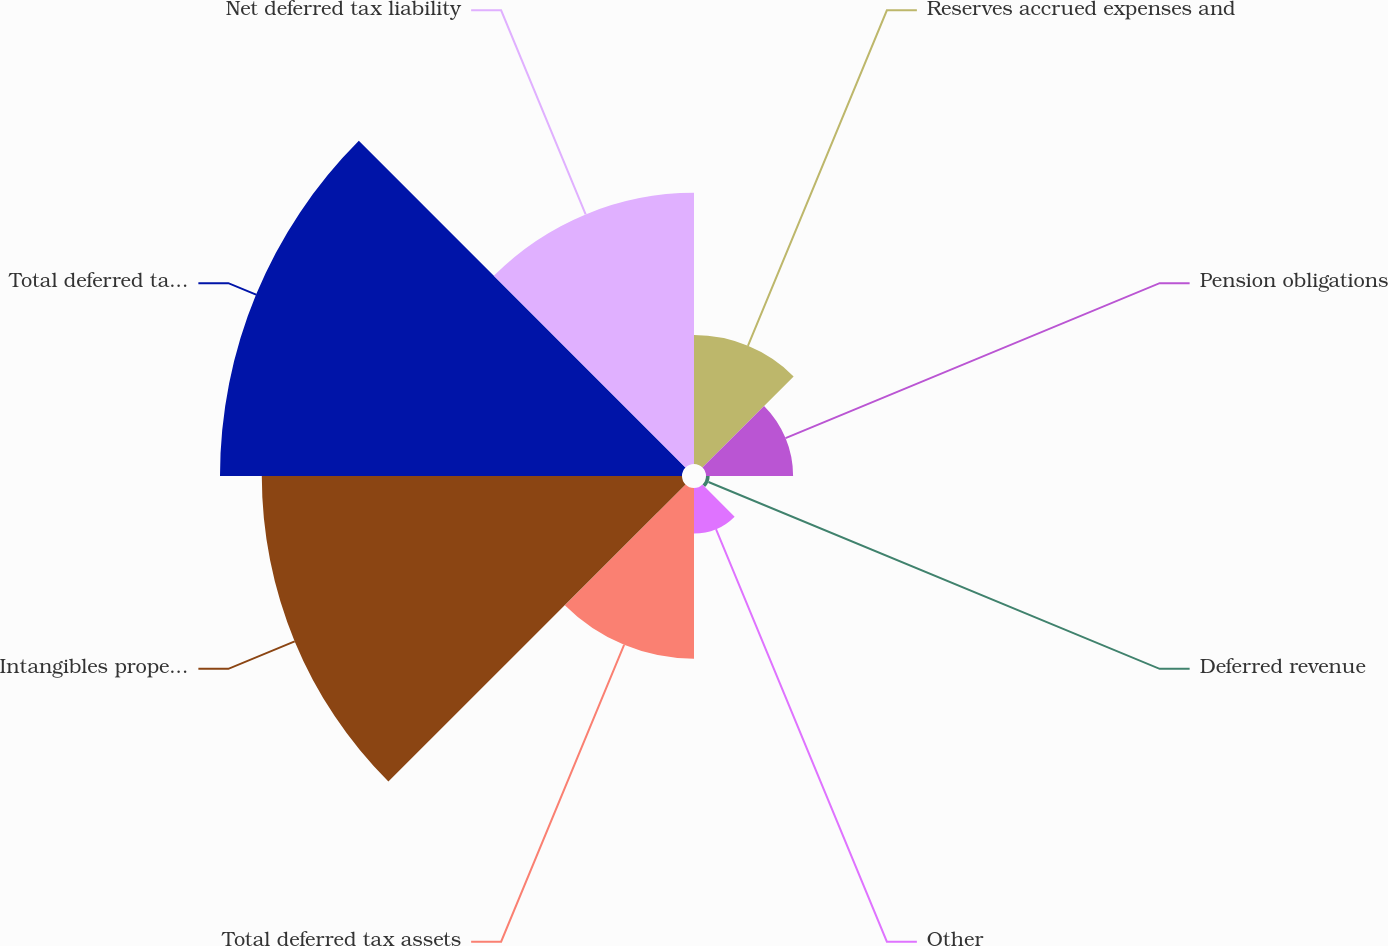Convert chart to OTSL. <chart><loc_0><loc_0><loc_500><loc_500><pie_chart><fcel>Reserves accrued expenses and<fcel>Pension obligations<fcel>Deferred revenue<fcel>Other<fcel>Total deferred tax assets<fcel>Intangibles property and<fcel>Total deferred tax liabilities<fcel>Net deferred tax liability<nl><fcel>8.11%<fcel>5.48%<fcel>0.23%<fcel>2.86%<fcel>10.74%<fcel>26.44%<fcel>29.07%<fcel>17.06%<nl></chart> 